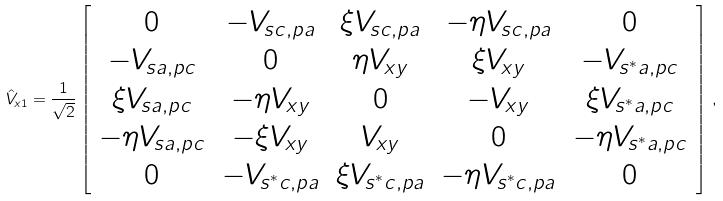<formula> <loc_0><loc_0><loc_500><loc_500>\hat { V } _ { x 1 } = \frac { 1 } { \sqrt { 2 } } \left [ \begin{array} { c c c c c } 0 & - V _ { s c , p a } & \xi V _ { s c , p a } & - \eta V _ { s c , p a } & 0 \\ - V _ { s a , p c } & 0 & \eta V _ { x y } & \xi V _ { x y } & - V _ { s ^ { * } a , p c } \\ \xi V _ { s a , p c } & - \eta V _ { x y } & 0 & - V _ { x y } & \xi V _ { s ^ { * } a , p c } \\ - \eta V _ { s a , p c } & - \xi V _ { x y } & V _ { x y } & 0 & - \eta V _ { s ^ { * } a , p c } \\ 0 & - V _ { s ^ { * } c , p a } & \xi V _ { s ^ { * } c , p a } & - \eta V _ { s ^ { * } c , p a } & 0 \\ \end{array} \right ] \, ,</formula> 